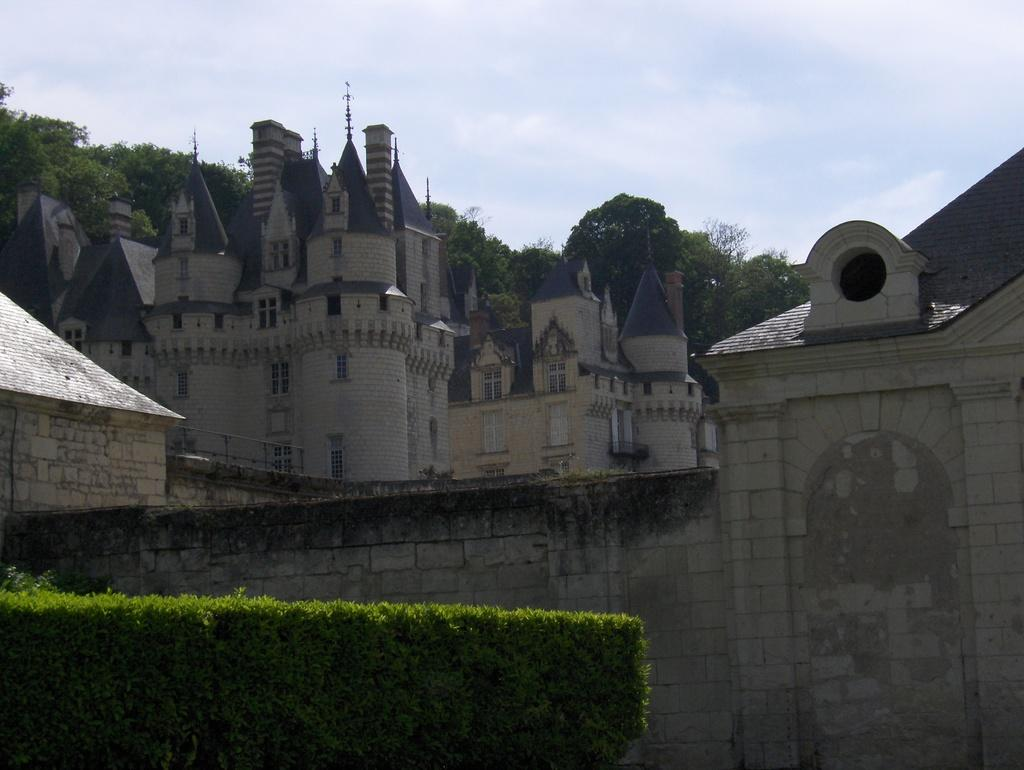What type of structures can be seen in the image? There are buildings in the image. What type of vegetation is present in the image? There are trees and plants in the image. What part of the natural environment is visible in the image? The sky is visible in the image. What type of knife is being used to cut the team's shame in the image? There is no knife, team, or shame present in the image. 